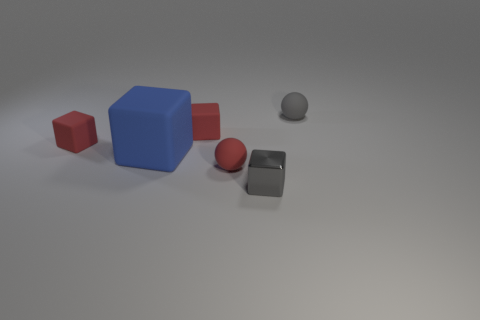There is another thing that is the same color as the small shiny object; what material is it?
Offer a very short reply. Rubber. What number of green things have the same size as the red sphere?
Give a very brief answer. 0. There is another gray thing that is the same shape as the large rubber thing; what is its material?
Keep it short and to the point. Metal. Does the small gray matte object have the same shape as the blue rubber thing?
Your answer should be very brief. No. What number of big rubber blocks are in front of the metal block?
Your answer should be compact. 0. There is a gray object behind the thing that is in front of the red rubber ball; what shape is it?
Keep it short and to the point. Sphere. There is a blue thing that is made of the same material as the red sphere; what is its shape?
Your answer should be very brief. Cube. Does the rubber sphere behind the large blue matte cube have the same size as the gray thing in front of the red ball?
Offer a very short reply. Yes. There is a red rubber object that is to the left of the blue rubber block; what is its shape?
Make the answer very short. Cube. What is the color of the large matte object?
Keep it short and to the point. Blue. 